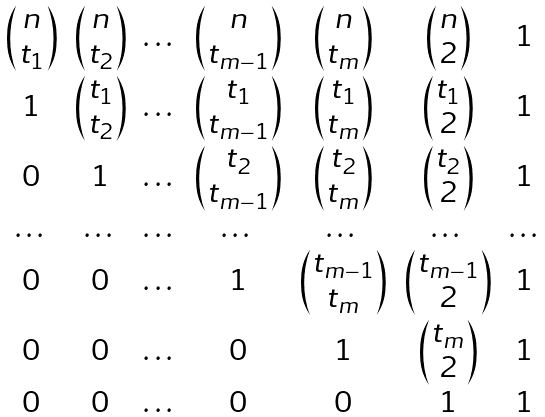<formula> <loc_0><loc_0><loc_500><loc_500>\begin{matrix} \begin{pmatrix} n \\ t _ { 1 } \end{pmatrix} & \begin{pmatrix} n \\ t _ { 2 } \end{pmatrix} & \dots & \begin{pmatrix} n \\ t _ { m - 1 } \end{pmatrix} & \begin{pmatrix} n \\ t _ { m } \end{pmatrix} & \begin{pmatrix} n \\ 2 \end{pmatrix} & 1 \\ 1 & \begin{pmatrix} t _ { 1 } \\ t _ { 2 } \end{pmatrix} & \dots & \begin{pmatrix} t _ { 1 } \\ t _ { m - 1 } \end{pmatrix} & \begin{pmatrix} t _ { 1 } \\ t _ { m } \end{pmatrix} & \begin{pmatrix} t _ { 1 } \\ 2 \end{pmatrix} & 1 \\ 0 & 1 & \dots & \begin{pmatrix} t _ { 2 } \\ t _ { m - 1 } \end{pmatrix} & \begin{pmatrix} t _ { 2 } \\ t _ { m } \end{pmatrix} & \begin{pmatrix} t _ { 2 } \\ 2 \end{pmatrix} & 1 \\ \dots & \dots & \dots & \dots & \dots & \dots & \dots \\ 0 & 0 & \dots & 1 & \begin{pmatrix} t _ { m - 1 } \\ t _ { m } \end{pmatrix} & \begin{pmatrix} t _ { m - 1 } \\ 2 \end{pmatrix} & 1 \\ 0 & 0 & \dots & 0 & 1 & \begin{pmatrix} t _ { m } \\ 2 \end{pmatrix} & 1 \\ 0 & 0 & \dots & 0 & 0 & 1 & 1 \end{matrix}</formula> 